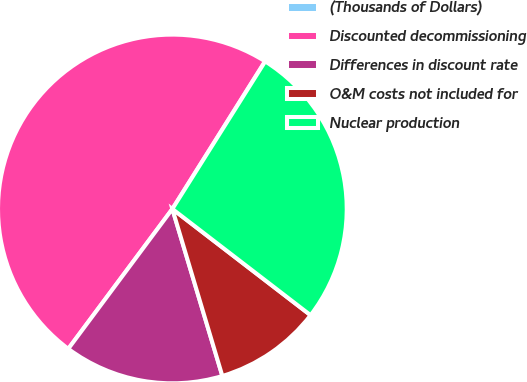<chart> <loc_0><loc_0><loc_500><loc_500><pie_chart><fcel>(Thousands of Dollars)<fcel>Discounted decommissioning<fcel>Differences in discount rate<fcel>O&M costs not included for<fcel>Nuclear production<nl><fcel>0.02%<fcel>48.73%<fcel>14.81%<fcel>9.94%<fcel>26.49%<nl></chart> 